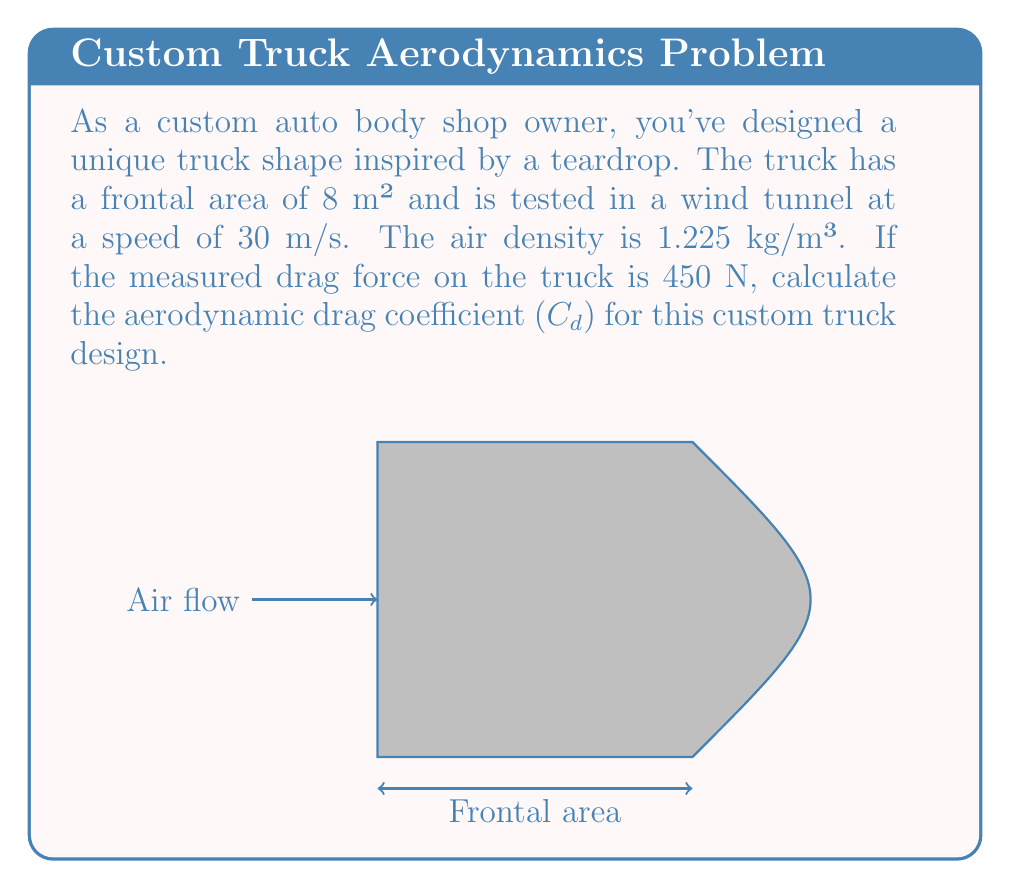Can you solve this math problem? To calculate the aerodynamic drag coefficient ($C_d$), we'll use the drag equation:

$$F_d = \frac{1}{2} \rho v^2 C_d A$$

Where:
$F_d$ = Drag force (N)
$\rho$ = Air density (kg/m³)
$v$ = Velocity (m/s)
$C_d$ = Drag coefficient (dimensionless)
$A$ = Frontal area (m²)

We need to solve for $C_d$. Let's rearrange the equation:

$$C_d = \frac{2F_d}{\rho v^2 A}$$

Now, let's substitute the given values:

$F_d = 450 \text{ N}$
$\rho = 1.225 \text{ kg/m³}$
$v = 30 \text{ m/s}$
$A = 8 \text{ m²}$

$$C_d = \frac{2 \cdot 450}{1.225 \cdot 30^2 \cdot 8}$$

Let's calculate step by step:

1) First, calculate $v^2$:
   $30^2 = 900$

2) Multiply the denominator:
   $1.225 \cdot 900 \cdot 8 = 8,820$

3) Multiply the numerator:
   $2 \cdot 450 = 900$

4) Divide:
   $C_d = \frac{900}{8,820} \approx 0.102$

Therefore, the aerodynamic drag coefficient for the custom truck design is approximately 0.102.
Answer: $C_d \approx 0.102$ 